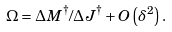Convert formula to latex. <formula><loc_0><loc_0><loc_500><loc_500>\Omega = \Delta M ^ { \dag } / \Delta J ^ { \dag } + O \left ( \delta ^ { 2 } \right ) .</formula> 